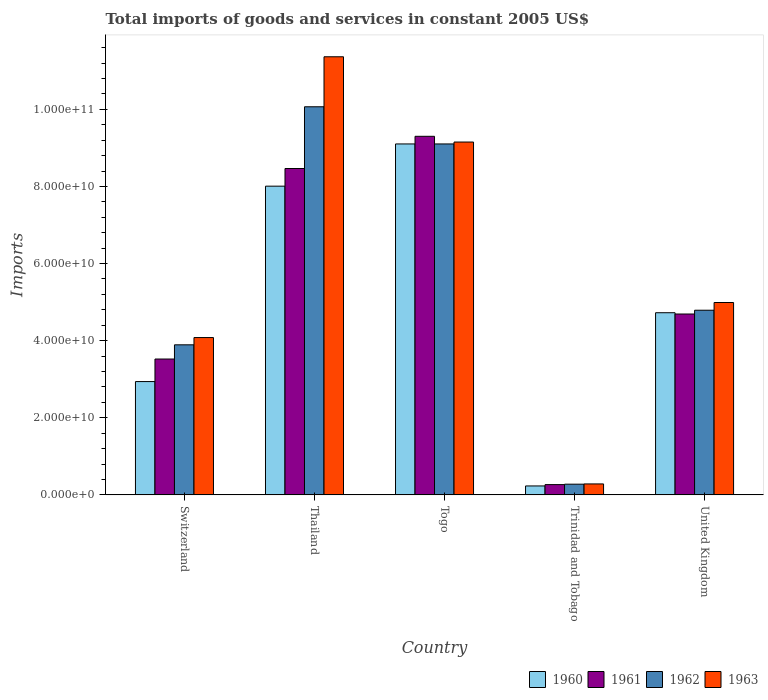How many different coloured bars are there?
Provide a succinct answer. 4. How many groups of bars are there?
Give a very brief answer. 5. Are the number of bars per tick equal to the number of legend labels?
Make the answer very short. Yes. Are the number of bars on each tick of the X-axis equal?
Make the answer very short. Yes. What is the label of the 5th group of bars from the left?
Ensure brevity in your answer.  United Kingdom. What is the total imports of goods and services in 1960 in Switzerland?
Offer a very short reply. 2.94e+1. Across all countries, what is the maximum total imports of goods and services in 1963?
Offer a terse response. 1.14e+11. Across all countries, what is the minimum total imports of goods and services in 1961?
Your answer should be very brief. 2.67e+09. In which country was the total imports of goods and services in 1961 maximum?
Provide a succinct answer. Togo. In which country was the total imports of goods and services in 1962 minimum?
Your response must be concise. Trinidad and Tobago. What is the total total imports of goods and services in 1963 in the graph?
Keep it short and to the point. 2.99e+11. What is the difference between the total imports of goods and services in 1960 in Togo and that in Trinidad and Tobago?
Your answer should be very brief. 8.87e+1. What is the difference between the total imports of goods and services in 1961 in United Kingdom and the total imports of goods and services in 1962 in Trinidad and Tobago?
Your answer should be compact. 4.41e+1. What is the average total imports of goods and services in 1961 per country?
Give a very brief answer. 5.25e+1. What is the difference between the total imports of goods and services of/in 1963 and total imports of goods and services of/in 1960 in Togo?
Your answer should be compact. 4.94e+08. What is the ratio of the total imports of goods and services in 1961 in Trinidad and Tobago to that in United Kingdom?
Give a very brief answer. 0.06. What is the difference between the highest and the second highest total imports of goods and services in 1963?
Your answer should be compact. 4.16e+1. What is the difference between the highest and the lowest total imports of goods and services in 1962?
Your response must be concise. 9.79e+1. Is the sum of the total imports of goods and services in 1960 in Switzerland and Trinidad and Tobago greater than the maximum total imports of goods and services in 1963 across all countries?
Offer a very short reply. No. What does the 3rd bar from the left in Trinidad and Tobago represents?
Provide a short and direct response. 1962. How many countries are there in the graph?
Provide a succinct answer. 5. Are the values on the major ticks of Y-axis written in scientific E-notation?
Ensure brevity in your answer.  Yes. Does the graph contain grids?
Your answer should be compact. No. How many legend labels are there?
Your response must be concise. 4. What is the title of the graph?
Ensure brevity in your answer.  Total imports of goods and services in constant 2005 US$. Does "1989" appear as one of the legend labels in the graph?
Provide a succinct answer. No. What is the label or title of the X-axis?
Offer a very short reply. Country. What is the label or title of the Y-axis?
Your answer should be very brief. Imports. What is the Imports of 1960 in Switzerland?
Offer a terse response. 2.94e+1. What is the Imports in 1961 in Switzerland?
Ensure brevity in your answer.  3.52e+1. What is the Imports of 1962 in Switzerland?
Ensure brevity in your answer.  3.89e+1. What is the Imports in 1963 in Switzerland?
Your answer should be very brief. 4.08e+1. What is the Imports of 1960 in Thailand?
Provide a succinct answer. 8.01e+1. What is the Imports in 1961 in Thailand?
Ensure brevity in your answer.  8.46e+1. What is the Imports of 1962 in Thailand?
Keep it short and to the point. 1.01e+11. What is the Imports in 1963 in Thailand?
Your answer should be very brief. 1.14e+11. What is the Imports of 1960 in Togo?
Offer a very short reply. 9.10e+1. What is the Imports in 1961 in Togo?
Keep it short and to the point. 9.30e+1. What is the Imports in 1962 in Togo?
Provide a succinct answer. 9.10e+1. What is the Imports in 1963 in Togo?
Your answer should be compact. 9.15e+1. What is the Imports of 1960 in Trinidad and Tobago?
Offer a very short reply. 2.32e+09. What is the Imports of 1961 in Trinidad and Tobago?
Provide a short and direct response. 2.67e+09. What is the Imports in 1962 in Trinidad and Tobago?
Offer a very short reply. 2.78e+09. What is the Imports in 1963 in Trinidad and Tobago?
Make the answer very short. 2.85e+09. What is the Imports in 1960 in United Kingdom?
Your answer should be very brief. 4.72e+1. What is the Imports of 1961 in United Kingdom?
Your response must be concise. 4.69e+1. What is the Imports in 1962 in United Kingdom?
Provide a succinct answer. 4.79e+1. What is the Imports in 1963 in United Kingdom?
Ensure brevity in your answer.  4.99e+1. Across all countries, what is the maximum Imports of 1960?
Keep it short and to the point. 9.10e+1. Across all countries, what is the maximum Imports of 1961?
Give a very brief answer. 9.30e+1. Across all countries, what is the maximum Imports in 1962?
Your answer should be very brief. 1.01e+11. Across all countries, what is the maximum Imports in 1963?
Make the answer very short. 1.14e+11. Across all countries, what is the minimum Imports in 1960?
Provide a succinct answer. 2.32e+09. Across all countries, what is the minimum Imports in 1961?
Ensure brevity in your answer.  2.67e+09. Across all countries, what is the minimum Imports in 1962?
Provide a succinct answer. 2.78e+09. Across all countries, what is the minimum Imports in 1963?
Your answer should be very brief. 2.85e+09. What is the total Imports of 1960 in the graph?
Make the answer very short. 2.50e+11. What is the total Imports of 1961 in the graph?
Your answer should be compact. 2.62e+11. What is the total Imports in 1962 in the graph?
Offer a very short reply. 2.81e+11. What is the total Imports of 1963 in the graph?
Make the answer very short. 2.99e+11. What is the difference between the Imports of 1960 in Switzerland and that in Thailand?
Ensure brevity in your answer.  -5.07e+1. What is the difference between the Imports of 1961 in Switzerland and that in Thailand?
Keep it short and to the point. -4.94e+1. What is the difference between the Imports in 1962 in Switzerland and that in Thailand?
Keep it short and to the point. -6.17e+1. What is the difference between the Imports in 1963 in Switzerland and that in Thailand?
Provide a succinct answer. -7.28e+1. What is the difference between the Imports of 1960 in Switzerland and that in Togo?
Offer a very short reply. -6.16e+1. What is the difference between the Imports in 1961 in Switzerland and that in Togo?
Provide a succinct answer. -5.78e+1. What is the difference between the Imports of 1962 in Switzerland and that in Togo?
Provide a short and direct response. -5.21e+1. What is the difference between the Imports in 1963 in Switzerland and that in Togo?
Offer a terse response. -5.07e+1. What is the difference between the Imports in 1960 in Switzerland and that in Trinidad and Tobago?
Make the answer very short. 2.71e+1. What is the difference between the Imports in 1961 in Switzerland and that in Trinidad and Tobago?
Your answer should be very brief. 3.26e+1. What is the difference between the Imports in 1962 in Switzerland and that in Trinidad and Tobago?
Your answer should be compact. 3.61e+1. What is the difference between the Imports in 1963 in Switzerland and that in Trinidad and Tobago?
Your response must be concise. 3.80e+1. What is the difference between the Imports in 1960 in Switzerland and that in United Kingdom?
Your response must be concise. -1.79e+1. What is the difference between the Imports in 1961 in Switzerland and that in United Kingdom?
Make the answer very short. -1.17e+1. What is the difference between the Imports in 1962 in Switzerland and that in United Kingdom?
Your response must be concise. -8.97e+09. What is the difference between the Imports in 1963 in Switzerland and that in United Kingdom?
Your answer should be compact. -9.09e+09. What is the difference between the Imports of 1960 in Thailand and that in Togo?
Offer a very short reply. -1.09e+1. What is the difference between the Imports in 1961 in Thailand and that in Togo?
Your answer should be compact. -8.35e+09. What is the difference between the Imports of 1962 in Thailand and that in Togo?
Give a very brief answer. 9.64e+09. What is the difference between the Imports in 1963 in Thailand and that in Togo?
Keep it short and to the point. 2.21e+1. What is the difference between the Imports of 1960 in Thailand and that in Trinidad and Tobago?
Provide a short and direct response. 7.77e+1. What is the difference between the Imports of 1961 in Thailand and that in Trinidad and Tobago?
Offer a terse response. 8.20e+1. What is the difference between the Imports of 1962 in Thailand and that in Trinidad and Tobago?
Ensure brevity in your answer.  9.79e+1. What is the difference between the Imports in 1963 in Thailand and that in Trinidad and Tobago?
Keep it short and to the point. 1.11e+11. What is the difference between the Imports in 1960 in Thailand and that in United Kingdom?
Make the answer very short. 3.28e+1. What is the difference between the Imports of 1961 in Thailand and that in United Kingdom?
Your answer should be very brief. 3.77e+1. What is the difference between the Imports in 1962 in Thailand and that in United Kingdom?
Provide a succinct answer. 5.28e+1. What is the difference between the Imports in 1963 in Thailand and that in United Kingdom?
Provide a succinct answer. 6.37e+1. What is the difference between the Imports in 1960 in Togo and that in Trinidad and Tobago?
Your response must be concise. 8.87e+1. What is the difference between the Imports in 1961 in Togo and that in Trinidad and Tobago?
Your answer should be very brief. 9.03e+1. What is the difference between the Imports in 1962 in Togo and that in Trinidad and Tobago?
Provide a short and direct response. 8.82e+1. What is the difference between the Imports in 1963 in Togo and that in Trinidad and Tobago?
Make the answer very short. 8.87e+1. What is the difference between the Imports of 1960 in Togo and that in United Kingdom?
Your answer should be very brief. 4.38e+1. What is the difference between the Imports of 1961 in Togo and that in United Kingdom?
Your response must be concise. 4.61e+1. What is the difference between the Imports of 1962 in Togo and that in United Kingdom?
Your answer should be compact. 4.31e+1. What is the difference between the Imports in 1963 in Togo and that in United Kingdom?
Offer a very short reply. 4.16e+1. What is the difference between the Imports in 1960 in Trinidad and Tobago and that in United Kingdom?
Give a very brief answer. -4.49e+1. What is the difference between the Imports in 1961 in Trinidad and Tobago and that in United Kingdom?
Ensure brevity in your answer.  -4.42e+1. What is the difference between the Imports of 1962 in Trinidad and Tobago and that in United Kingdom?
Your response must be concise. -4.51e+1. What is the difference between the Imports of 1963 in Trinidad and Tobago and that in United Kingdom?
Your answer should be very brief. -4.70e+1. What is the difference between the Imports of 1960 in Switzerland and the Imports of 1961 in Thailand?
Your answer should be very brief. -5.53e+1. What is the difference between the Imports of 1960 in Switzerland and the Imports of 1962 in Thailand?
Your response must be concise. -7.13e+1. What is the difference between the Imports in 1960 in Switzerland and the Imports in 1963 in Thailand?
Provide a succinct answer. -8.42e+1. What is the difference between the Imports of 1961 in Switzerland and the Imports of 1962 in Thailand?
Your answer should be compact. -6.54e+1. What is the difference between the Imports of 1961 in Switzerland and the Imports of 1963 in Thailand?
Provide a short and direct response. -7.84e+1. What is the difference between the Imports of 1962 in Switzerland and the Imports of 1963 in Thailand?
Your answer should be compact. -7.47e+1. What is the difference between the Imports in 1960 in Switzerland and the Imports in 1961 in Togo?
Offer a terse response. -6.36e+1. What is the difference between the Imports of 1960 in Switzerland and the Imports of 1962 in Togo?
Offer a very short reply. -6.16e+1. What is the difference between the Imports in 1960 in Switzerland and the Imports in 1963 in Togo?
Provide a succinct answer. -6.21e+1. What is the difference between the Imports of 1961 in Switzerland and the Imports of 1962 in Togo?
Give a very brief answer. -5.58e+1. What is the difference between the Imports in 1961 in Switzerland and the Imports in 1963 in Togo?
Provide a succinct answer. -5.63e+1. What is the difference between the Imports in 1962 in Switzerland and the Imports in 1963 in Togo?
Provide a succinct answer. -5.26e+1. What is the difference between the Imports of 1960 in Switzerland and the Imports of 1961 in Trinidad and Tobago?
Provide a short and direct response. 2.67e+1. What is the difference between the Imports of 1960 in Switzerland and the Imports of 1962 in Trinidad and Tobago?
Give a very brief answer. 2.66e+1. What is the difference between the Imports of 1960 in Switzerland and the Imports of 1963 in Trinidad and Tobago?
Your response must be concise. 2.65e+1. What is the difference between the Imports in 1961 in Switzerland and the Imports in 1962 in Trinidad and Tobago?
Offer a very short reply. 3.25e+1. What is the difference between the Imports of 1961 in Switzerland and the Imports of 1963 in Trinidad and Tobago?
Ensure brevity in your answer.  3.24e+1. What is the difference between the Imports of 1962 in Switzerland and the Imports of 1963 in Trinidad and Tobago?
Keep it short and to the point. 3.61e+1. What is the difference between the Imports in 1960 in Switzerland and the Imports in 1961 in United Kingdom?
Your answer should be very brief. -1.75e+1. What is the difference between the Imports in 1960 in Switzerland and the Imports in 1962 in United Kingdom?
Your answer should be compact. -1.85e+1. What is the difference between the Imports in 1960 in Switzerland and the Imports in 1963 in United Kingdom?
Provide a short and direct response. -2.05e+1. What is the difference between the Imports in 1961 in Switzerland and the Imports in 1962 in United Kingdom?
Keep it short and to the point. -1.27e+1. What is the difference between the Imports of 1961 in Switzerland and the Imports of 1963 in United Kingdom?
Offer a very short reply. -1.47e+1. What is the difference between the Imports in 1962 in Switzerland and the Imports in 1963 in United Kingdom?
Keep it short and to the point. -1.10e+1. What is the difference between the Imports of 1960 in Thailand and the Imports of 1961 in Togo?
Make the answer very short. -1.29e+1. What is the difference between the Imports of 1960 in Thailand and the Imports of 1962 in Togo?
Offer a terse response. -1.09e+1. What is the difference between the Imports in 1960 in Thailand and the Imports in 1963 in Togo?
Offer a terse response. -1.14e+1. What is the difference between the Imports of 1961 in Thailand and the Imports of 1962 in Togo?
Provide a short and direct response. -6.37e+09. What is the difference between the Imports in 1961 in Thailand and the Imports in 1963 in Togo?
Give a very brief answer. -6.87e+09. What is the difference between the Imports of 1962 in Thailand and the Imports of 1963 in Togo?
Provide a succinct answer. 9.15e+09. What is the difference between the Imports of 1960 in Thailand and the Imports of 1961 in Trinidad and Tobago?
Provide a succinct answer. 7.74e+1. What is the difference between the Imports in 1960 in Thailand and the Imports in 1962 in Trinidad and Tobago?
Keep it short and to the point. 7.73e+1. What is the difference between the Imports in 1960 in Thailand and the Imports in 1963 in Trinidad and Tobago?
Provide a succinct answer. 7.72e+1. What is the difference between the Imports of 1961 in Thailand and the Imports of 1962 in Trinidad and Tobago?
Ensure brevity in your answer.  8.19e+1. What is the difference between the Imports of 1961 in Thailand and the Imports of 1963 in Trinidad and Tobago?
Your answer should be very brief. 8.18e+1. What is the difference between the Imports in 1962 in Thailand and the Imports in 1963 in Trinidad and Tobago?
Keep it short and to the point. 9.78e+1. What is the difference between the Imports of 1960 in Thailand and the Imports of 1961 in United Kingdom?
Make the answer very short. 3.32e+1. What is the difference between the Imports in 1960 in Thailand and the Imports in 1962 in United Kingdom?
Offer a very short reply. 3.22e+1. What is the difference between the Imports of 1960 in Thailand and the Imports of 1963 in United Kingdom?
Ensure brevity in your answer.  3.02e+1. What is the difference between the Imports in 1961 in Thailand and the Imports in 1962 in United Kingdom?
Offer a terse response. 3.68e+1. What is the difference between the Imports in 1961 in Thailand and the Imports in 1963 in United Kingdom?
Ensure brevity in your answer.  3.48e+1. What is the difference between the Imports in 1962 in Thailand and the Imports in 1963 in United Kingdom?
Provide a succinct answer. 5.08e+1. What is the difference between the Imports of 1960 in Togo and the Imports of 1961 in Trinidad and Tobago?
Ensure brevity in your answer.  8.84e+1. What is the difference between the Imports of 1960 in Togo and the Imports of 1962 in Trinidad and Tobago?
Make the answer very short. 8.82e+1. What is the difference between the Imports in 1960 in Togo and the Imports in 1963 in Trinidad and Tobago?
Provide a short and direct response. 8.82e+1. What is the difference between the Imports in 1961 in Togo and the Imports in 1962 in Trinidad and Tobago?
Your answer should be very brief. 9.02e+1. What is the difference between the Imports of 1961 in Togo and the Imports of 1963 in Trinidad and Tobago?
Ensure brevity in your answer.  9.02e+1. What is the difference between the Imports in 1962 in Togo and the Imports in 1963 in Trinidad and Tobago?
Offer a very short reply. 8.82e+1. What is the difference between the Imports in 1960 in Togo and the Imports in 1961 in United Kingdom?
Keep it short and to the point. 4.41e+1. What is the difference between the Imports of 1960 in Togo and the Imports of 1962 in United Kingdom?
Your response must be concise. 4.31e+1. What is the difference between the Imports of 1960 in Togo and the Imports of 1963 in United Kingdom?
Give a very brief answer. 4.11e+1. What is the difference between the Imports in 1961 in Togo and the Imports in 1962 in United Kingdom?
Make the answer very short. 4.51e+1. What is the difference between the Imports of 1961 in Togo and the Imports of 1963 in United Kingdom?
Your response must be concise. 4.31e+1. What is the difference between the Imports in 1962 in Togo and the Imports in 1963 in United Kingdom?
Your response must be concise. 4.11e+1. What is the difference between the Imports of 1960 in Trinidad and Tobago and the Imports of 1961 in United Kingdom?
Your answer should be compact. -4.46e+1. What is the difference between the Imports in 1960 in Trinidad and Tobago and the Imports in 1962 in United Kingdom?
Your answer should be compact. -4.56e+1. What is the difference between the Imports in 1960 in Trinidad and Tobago and the Imports in 1963 in United Kingdom?
Your answer should be very brief. -4.76e+1. What is the difference between the Imports in 1961 in Trinidad and Tobago and the Imports in 1962 in United Kingdom?
Offer a terse response. -4.52e+1. What is the difference between the Imports of 1961 in Trinidad and Tobago and the Imports of 1963 in United Kingdom?
Give a very brief answer. -4.72e+1. What is the difference between the Imports in 1962 in Trinidad and Tobago and the Imports in 1963 in United Kingdom?
Offer a very short reply. -4.71e+1. What is the average Imports in 1960 per country?
Provide a short and direct response. 5.00e+1. What is the average Imports of 1961 per country?
Your answer should be very brief. 5.25e+1. What is the average Imports in 1962 per country?
Give a very brief answer. 5.63e+1. What is the average Imports of 1963 per country?
Your answer should be compact. 5.97e+1. What is the difference between the Imports of 1960 and Imports of 1961 in Switzerland?
Provide a succinct answer. -5.85e+09. What is the difference between the Imports in 1960 and Imports in 1962 in Switzerland?
Offer a terse response. -9.53e+09. What is the difference between the Imports of 1960 and Imports of 1963 in Switzerland?
Offer a very short reply. -1.14e+1. What is the difference between the Imports in 1961 and Imports in 1962 in Switzerland?
Ensure brevity in your answer.  -3.69e+09. What is the difference between the Imports of 1961 and Imports of 1963 in Switzerland?
Give a very brief answer. -5.57e+09. What is the difference between the Imports of 1962 and Imports of 1963 in Switzerland?
Make the answer very short. -1.88e+09. What is the difference between the Imports of 1960 and Imports of 1961 in Thailand?
Your answer should be very brief. -4.58e+09. What is the difference between the Imports in 1960 and Imports in 1962 in Thailand?
Your answer should be compact. -2.06e+1. What is the difference between the Imports of 1960 and Imports of 1963 in Thailand?
Keep it short and to the point. -3.36e+1. What is the difference between the Imports of 1961 and Imports of 1962 in Thailand?
Provide a succinct answer. -1.60e+1. What is the difference between the Imports of 1961 and Imports of 1963 in Thailand?
Your answer should be very brief. -2.90e+1. What is the difference between the Imports of 1962 and Imports of 1963 in Thailand?
Offer a terse response. -1.30e+1. What is the difference between the Imports in 1960 and Imports in 1961 in Togo?
Your response must be concise. -1.98e+09. What is the difference between the Imports in 1960 and Imports in 1962 in Togo?
Your response must be concise. 0. What is the difference between the Imports of 1960 and Imports of 1963 in Togo?
Make the answer very short. -4.94e+08. What is the difference between the Imports in 1961 and Imports in 1962 in Togo?
Give a very brief answer. 1.98e+09. What is the difference between the Imports of 1961 and Imports of 1963 in Togo?
Make the answer very short. 1.48e+09. What is the difference between the Imports of 1962 and Imports of 1963 in Togo?
Your answer should be very brief. -4.94e+08. What is the difference between the Imports in 1960 and Imports in 1961 in Trinidad and Tobago?
Keep it short and to the point. -3.48e+08. What is the difference between the Imports of 1960 and Imports of 1962 in Trinidad and Tobago?
Give a very brief answer. -4.60e+08. What is the difference between the Imports in 1960 and Imports in 1963 in Trinidad and Tobago?
Your answer should be compact. -5.24e+08. What is the difference between the Imports of 1961 and Imports of 1962 in Trinidad and Tobago?
Offer a very short reply. -1.12e+08. What is the difference between the Imports of 1961 and Imports of 1963 in Trinidad and Tobago?
Ensure brevity in your answer.  -1.77e+08. What is the difference between the Imports of 1962 and Imports of 1963 in Trinidad and Tobago?
Ensure brevity in your answer.  -6.48e+07. What is the difference between the Imports of 1960 and Imports of 1961 in United Kingdom?
Ensure brevity in your answer.  3.32e+08. What is the difference between the Imports in 1960 and Imports in 1962 in United Kingdom?
Your answer should be compact. -6.50e+08. What is the difference between the Imports of 1960 and Imports of 1963 in United Kingdom?
Your response must be concise. -2.65e+09. What is the difference between the Imports in 1961 and Imports in 1962 in United Kingdom?
Your response must be concise. -9.83e+08. What is the difference between the Imports in 1961 and Imports in 1963 in United Kingdom?
Ensure brevity in your answer.  -2.98e+09. What is the difference between the Imports in 1962 and Imports in 1963 in United Kingdom?
Keep it short and to the point. -2.00e+09. What is the ratio of the Imports in 1960 in Switzerland to that in Thailand?
Give a very brief answer. 0.37. What is the ratio of the Imports in 1961 in Switzerland to that in Thailand?
Provide a short and direct response. 0.42. What is the ratio of the Imports of 1962 in Switzerland to that in Thailand?
Provide a short and direct response. 0.39. What is the ratio of the Imports of 1963 in Switzerland to that in Thailand?
Give a very brief answer. 0.36. What is the ratio of the Imports of 1960 in Switzerland to that in Togo?
Provide a succinct answer. 0.32. What is the ratio of the Imports of 1961 in Switzerland to that in Togo?
Provide a succinct answer. 0.38. What is the ratio of the Imports of 1962 in Switzerland to that in Togo?
Make the answer very short. 0.43. What is the ratio of the Imports of 1963 in Switzerland to that in Togo?
Provide a short and direct response. 0.45. What is the ratio of the Imports in 1960 in Switzerland to that in Trinidad and Tobago?
Provide a succinct answer. 12.66. What is the ratio of the Imports in 1961 in Switzerland to that in Trinidad and Tobago?
Your answer should be very brief. 13.2. What is the ratio of the Imports of 1962 in Switzerland to that in Trinidad and Tobago?
Provide a short and direct response. 14. What is the ratio of the Imports in 1963 in Switzerland to that in Trinidad and Tobago?
Provide a succinct answer. 14.34. What is the ratio of the Imports of 1960 in Switzerland to that in United Kingdom?
Your answer should be very brief. 0.62. What is the ratio of the Imports in 1961 in Switzerland to that in United Kingdom?
Your answer should be compact. 0.75. What is the ratio of the Imports of 1962 in Switzerland to that in United Kingdom?
Your response must be concise. 0.81. What is the ratio of the Imports of 1963 in Switzerland to that in United Kingdom?
Your answer should be compact. 0.82. What is the ratio of the Imports of 1960 in Thailand to that in Togo?
Provide a succinct answer. 0.88. What is the ratio of the Imports in 1961 in Thailand to that in Togo?
Your answer should be very brief. 0.91. What is the ratio of the Imports of 1962 in Thailand to that in Togo?
Your answer should be very brief. 1.11. What is the ratio of the Imports in 1963 in Thailand to that in Togo?
Your answer should be compact. 1.24. What is the ratio of the Imports in 1960 in Thailand to that in Trinidad and Tobago?
Provide a succinct answer. 34.5. What is the ratio of the Imports of 1961 in Thailand to that in Trinidad and Tobago?
Your response must be concise. 31.72. What is the ratio of the Imports of 1962 in Thailand to that in Trinidad and Tobago?
Provide a succinct answer. 36.2. What is the ratio of the Imports of 1963 in Thailand to that in Trinidad and Tobago?
Provide a short and direct response. 39.93. What is the ratio of the Imports in 1960 in Thailand to that in United Kingdom?
Keep it short and to the point. 1.69. What is the ratio of the Imports of 1961 in Thailand to that in United Kingdom?
Your answer should be very brief. 1.8. What is the ratio of the Imports in 1962 in Thailand to that in United Kingdom?
Ensure brevity in your answer.  2.1. What is the ratio of the Imports in 1963 in Thailand to that in United Kingdom?
Your answer should be compact. 2.28. What is the ratio of the Imports in 1960 in Togo to that in Trinidad and Tobago?
Offer a very short reply. 39.21. What is the ratio of the Imports in 1961 in Togo to that in Trinidad and Tobago?
Provide a short and direct response. 34.85. What is the ratio of the Imports in 1962 in Togo to that in Trinidad and Tobago?
Provide a succinct answer. 32.73. What is the ratio of the Imports in 1963 in Togo to that in Trinidad and Tobago?
Offer a very short reply. 32.16. What is the ratio of the Imports in 1960 in Togo to that in United Kingdom?
Offer a very short reply. 1.93. What is the ratio of the Imports of 1961 in Togo to that in United Kingdom?
Your answer should be compact. 1.98. What is the ratio of the Imports in 1962 in Togo to that in United Kingdom?
Your answer should be compact. 1.9. What is the ratio of the Imports of 1963 in Togo to that in United Kingdom?
Offer a very short reply. 1.83. What is the ratio of the Imports of 1960 in Trinidad and Tobago to that in United Kingdom?
Keep it short and to the point. 0.05. What is the ratio of the Imports in 1961 in Trinidad and Tobago to that in United Kingdom?
Keep it short and to the point. 0.06. What is the ratio of the Imports in 1962 in Trinidad and Tobago to that in United Kingdom?
Make the answer very short. 0.06. What is the ratio of the Imports in 1963 in Trinidad and Tobago to that in United Kingdom?
Provide a succinct answer. 0.06. What is the difference between the highest and the second highest Imports in 1960?
Your response must be concise. 1.09e+1. What is the difference between the highest and the second highest Imports of 1961?
Make the answer very short. 8.35e+09. What is the difference between the highest and the second highest Imports in 1962?
Keep it short and to the point. 9.64e+09. What is the difference between the highest and the second highest Imports in 1963?
Give a very brief answer. 2.21e+1. What is the difference between the highest and the lowest Imports of 1960?
Your response must be concise. 8.87e+1. What is the difference between the highest and the lowest Imports of 1961?
Your answer should be compact. 9.03e+1. What is the difference between the highest and the lowest Imports in 1962?
Make the answer very short. 9.79e+1. What is the difference between the highest and the lowest Imports of 1963?
Ensure brevity in your answer.  1.11e+11. 